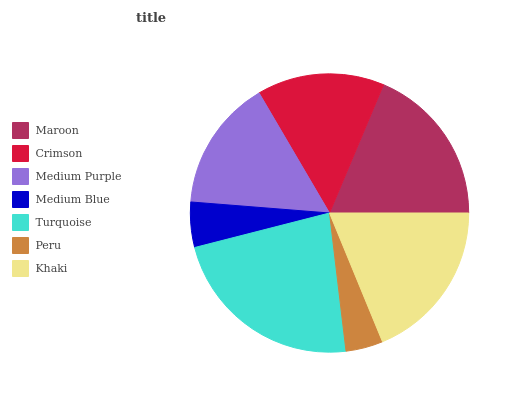Is Peru the minimum?
Answer yes or no. Yes. Is Turquoise the maximum?
Answer yes or no. Yes. Is Crimson the minimum?
Answer yes or no. No. Is Crimson the maximum?
Answer yes or no. No. Is Maroon greater than Crimson?
Answer yes or no. Yes. Is Crimson less than Maroon?
Answer yes or no. Yes. Is Crimson greater than Maroon?
Answer yes or no. No. Is Maroon less than Crimson?
Answer yes or no. No. Is Medium Purple the high median?
Answer yes or no. Yes. Is Medium Purple the low median?
Answer yes or no. Yes. Is Turquoise the high median?
Answer yes or no. No. Is Khaki the low median?
Answer yes or no. No. 